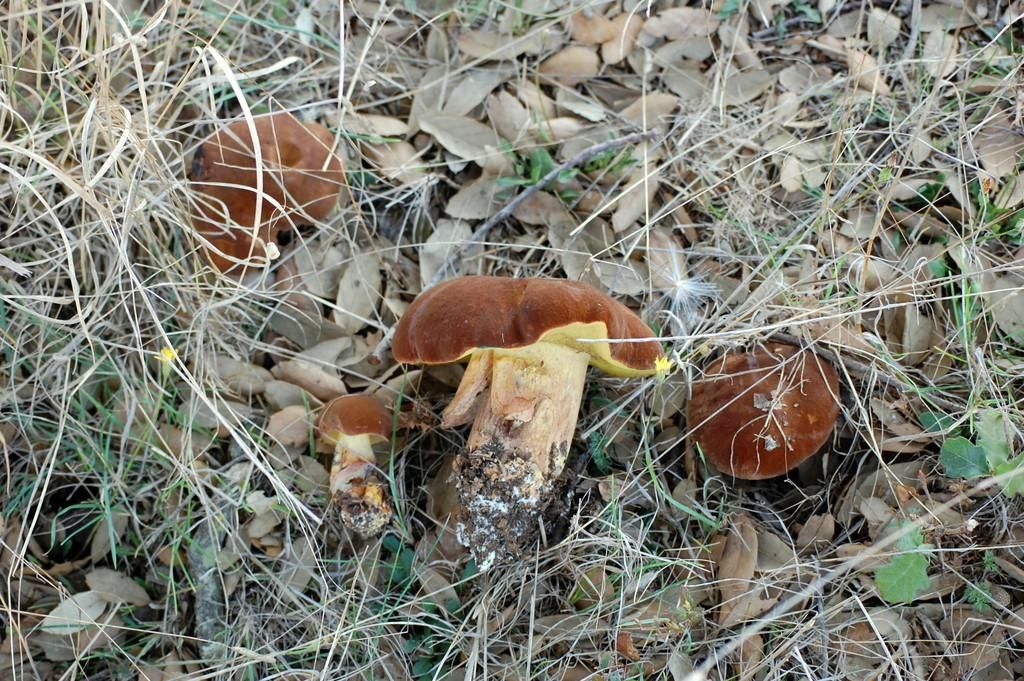What type of mushrooms can be seen in the image? There are brown color mushrooms in the image. Where are the mushrooms located? The mushrooms are growing on the ground. What type of vegetation is visible in the image? Dry grass is visible in the image. What else can be found on the ground in the image? Dry leaves are present in the image. How does the wound heal in the image? There is no wound present in the image; it features mushrooms growing on the ground. What type of exchange is taking place between the mushrooms and the dry leaves? There is no exchange between the mushrooms and the dry leaves in the image; they are simply present in the same environment. 